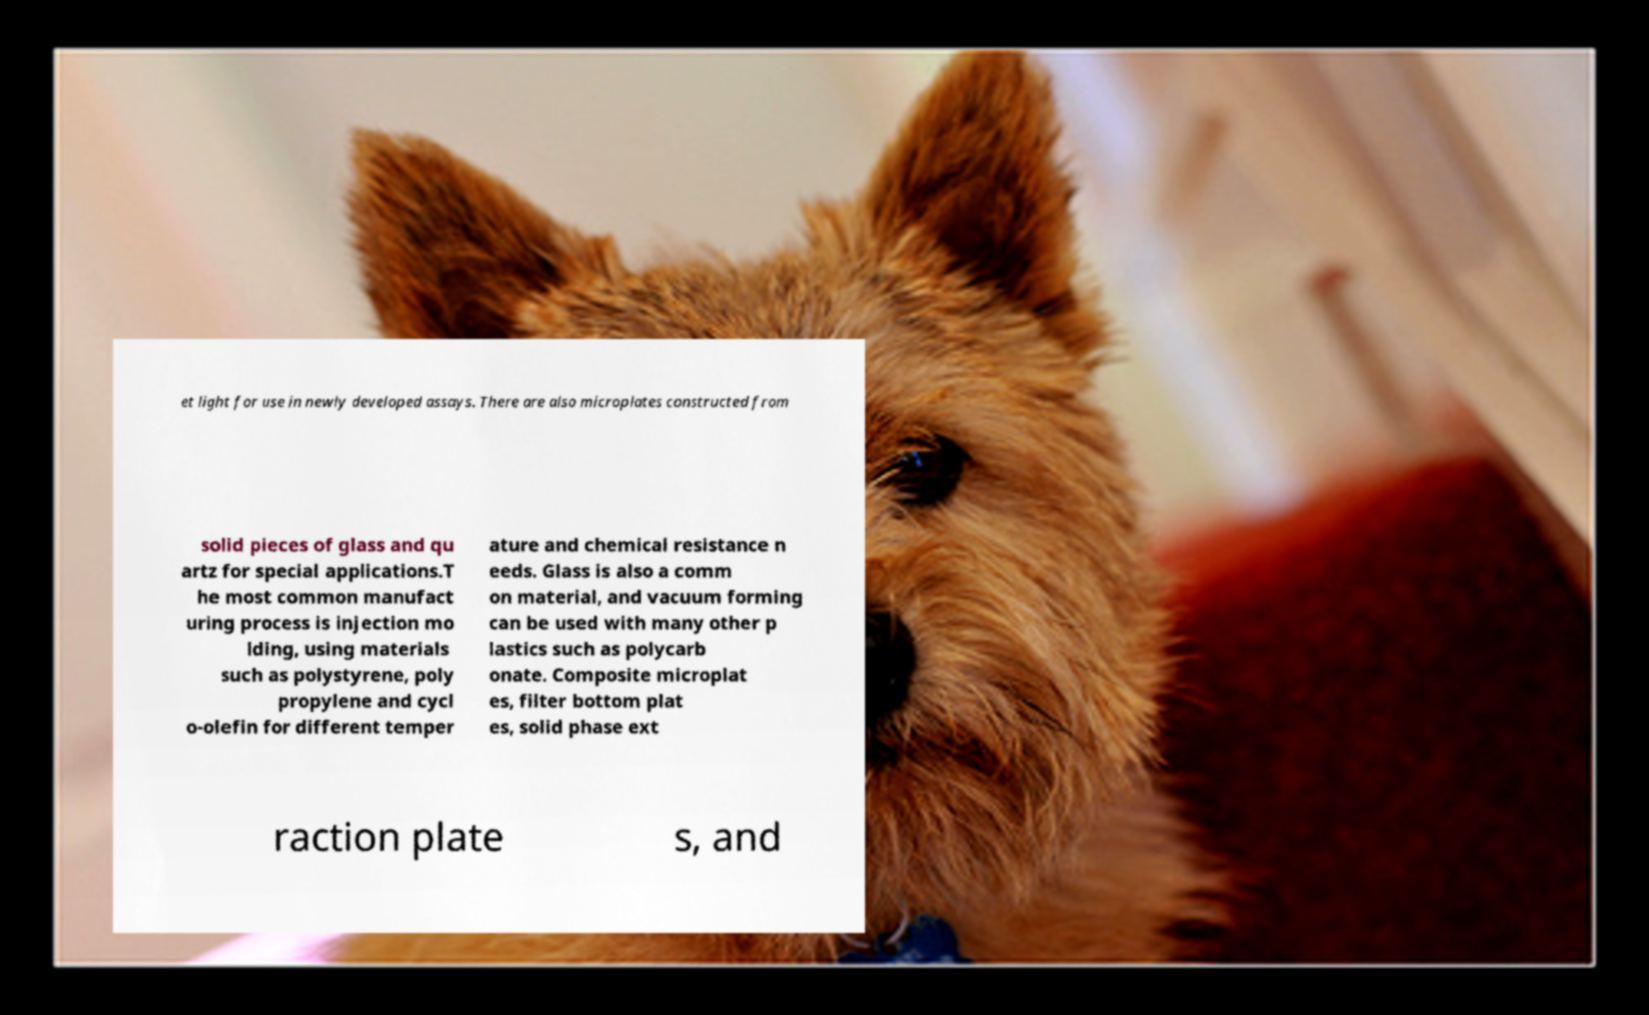Could you extract and type out the text from this image? et light for use in newly developed assays. There are also microplates constructed from solid pieces of glass and qu artz for special applications.T he most common manufact uring process is injection mo lding, using materials such as polystyrene, poly propylene and cycl o-olefin for different temper ature and chemical resistance n eeds. Glass is also a comm on material, and vacuum forming can be used with many other p lastics such as polycarb onate. Composite microplat es, filter bottom plat es, solid phase ext raction plate s, and 